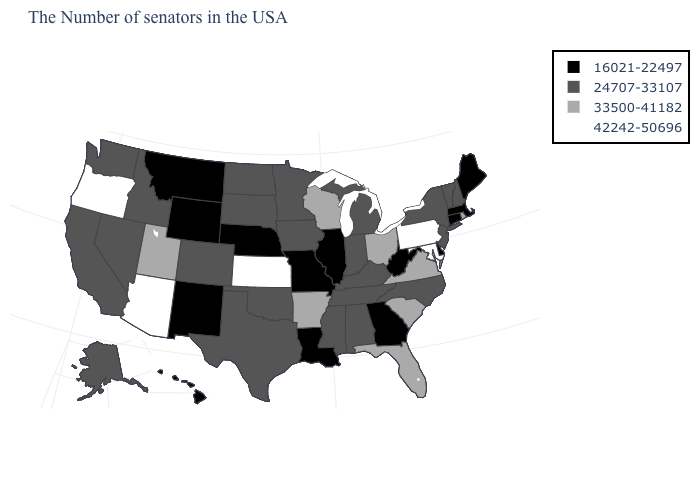Which states hav the highest value in the West?
Answer briefly. Arizona, Oregon. Which states have the lowest value in the USA?
Be succinct. Maine, Massachusetts, Connecticut, Delaware, West Virginia, Georgia, Illinois, Louisiana, Missouri, Nebraska, Wyoming, New Mexico, Montana, Hawaii. Name the states that have a value in the range 24707-33107?
Answer briefly. New Hampshire, Vermont, New York, New Jersey, North Carolina, Michigan, Kentucky, Indiana, Alabama, Tennessee, Mississippi, Minnesota, Iowa, Oklahoma, Texas, South Dakota, North Dakota, Colorado, Idaho, Nevada, California, Washington, Alaska. How many symbols are there in the legend?
Write a very short answer. 4. What is the highest value in the USA?
Concise answer only. 42242-50696. What is the highest value in the West ?
Quick response, please. 42242-50696. Among the states that border Utah , which have the highest value?
Write a very short answer. Arizona. Does Hawaii have the highest value in the USA?
Keep it brief. No. Name the states that have a value in the range 42242-50696?
Give a very brief answer. Maryland, Pennsylvania, Kansas, Arizona, Oregon. Which states hav the highest value in the MidWest?
Concise answer only. Kansas. Does the map have missing data?
Concise answer only. No. Which states have the lowest value in the USA?
Keep it brief. Maine, Massachusetts, Connecticut, Delaware, West Virginia, Georgia, Illinois, Louisiana, Missouri, Nebraska, Wyoming, New Mexico, Montana, Hawaii. What is the value of Michigan?
Write a very short answer. 24707-33107. Does the map have missing data?
Quick response, please. No. Does Maine have the highest value in the USA?
Keep it brief. No. 